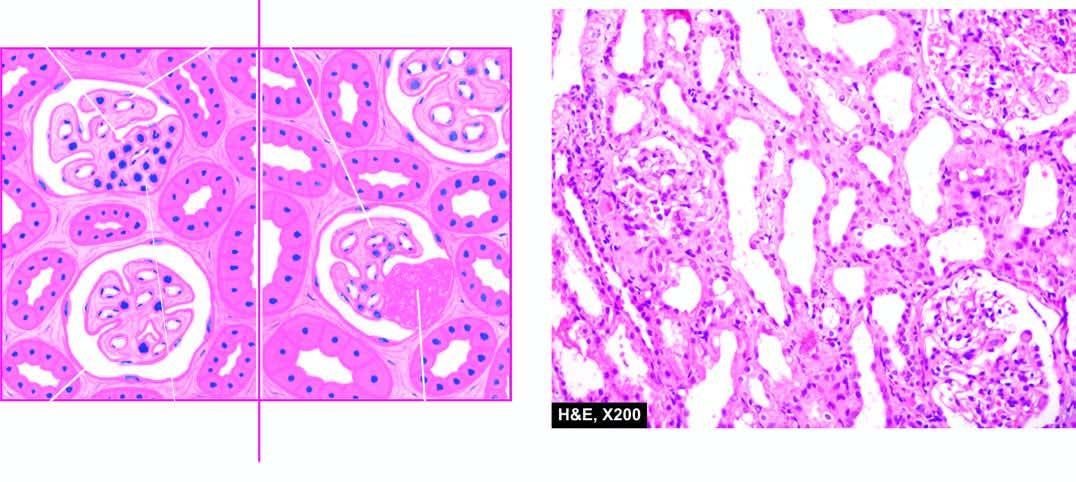what are focal and segmental involvement of the glomeruli by sclerosis and hyalinosis and mesangial hypercellularity?
Answer the question using a single word or phrase. The features 